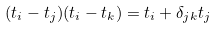<formula> <loc_0><loc_0><loc_500><loc_500>( t _ { i } - t _ { j } ) ( t _ { i } - t _ { k } ) = t _ { i } + \delta _ { j k } t _ { j }</formula> 